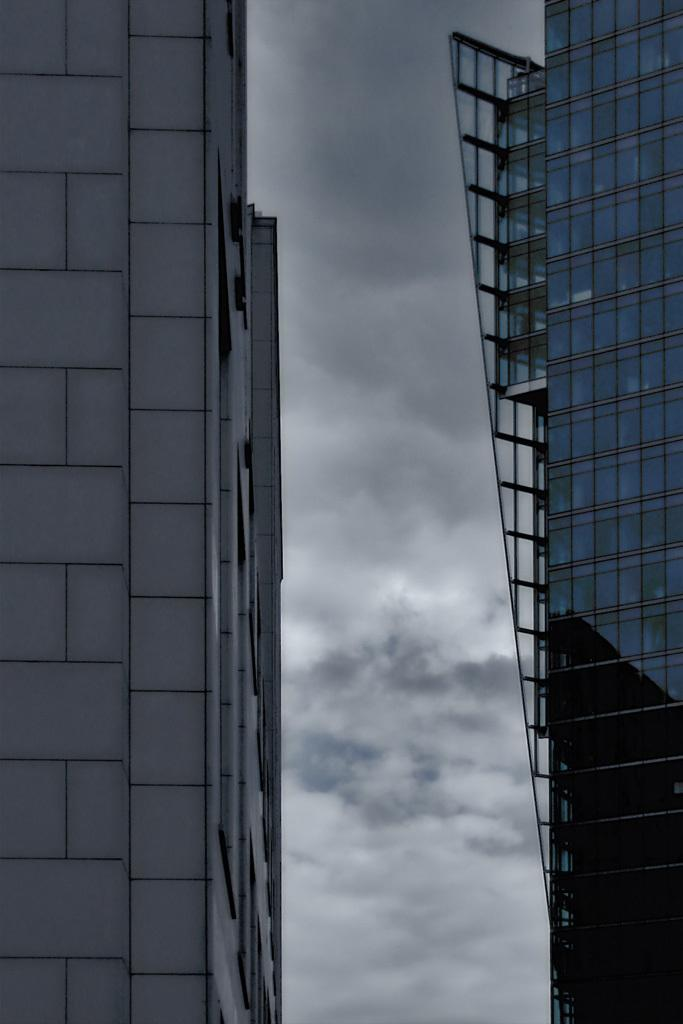What structures can be seen in the image? There are buildings in the image. What can be seen in the sky in the background of the image? There are clouds in the sky in the background of the image. How many cows can be seen grazing in the image? There are no cows present in the image; it features buildings and clouds in the sky. What type of cherry is being used as a decoration on the buildings in the image? There are no cherries present in the image; it only features buildings and clouds in the sky. 